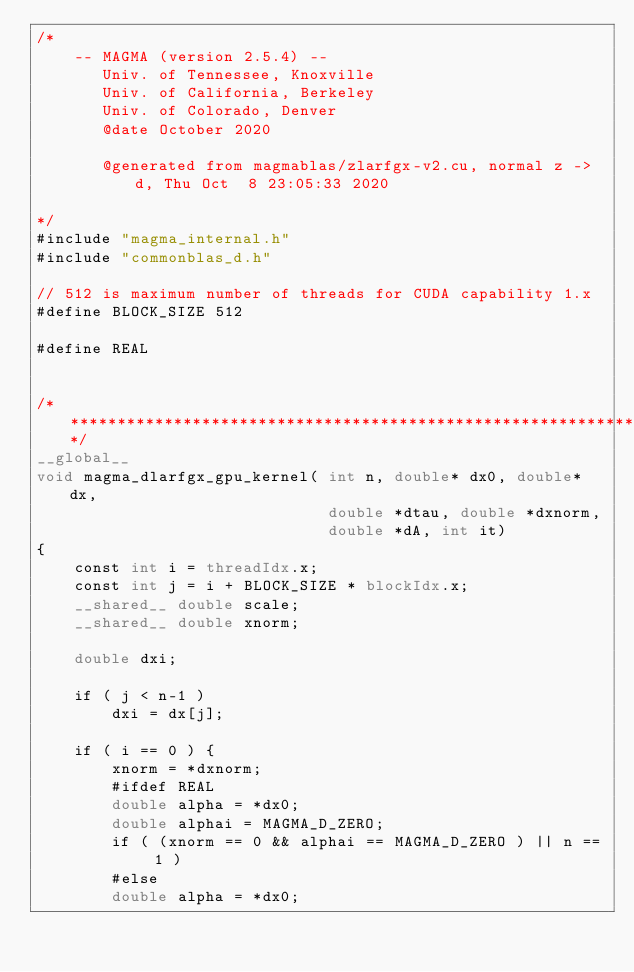<code> <loc_0><loc_0><loc_500><loc_500><_Cuda_>/*
    -- MAGMA (version 2.5.4) --
       Univ. of Tennessee, Knoxville
       Univ. of California, Berkeley
       Univ. of Colorado, Denver
       @date October 2020

       @generated from magmablas/zlarfgx-v2.cu, normal z -> d, Thu Oct  8 23:05:33 2020

*/
#include "magma_internal.h"
#include "commonblas_d.h"

// 512 is maximum number of threads for CUDA capability 1.x
#define BLOCK_SIZE 512

#define REAL


/******************************************************************************/
__global__
void magma_dlarfgx_gpu_kernel( int n, double* dx0, double* dx,
                               double *dtau, double *dxnorm,
                               double *dA, int it)
{
    const int i = threadIdx.x;
    const int j = i + BLOCK_SIZE * blockIdx.x;
    __shared__ double scale;
    __shared__ double xnorm;
  
    double dxi;

    if ( j < n-1 )
        dxi = dx[j];
  
    if ( i == 0 ) {
        xnorm = *dxnorm;
        #ifdef REAL
        double alpha = *dx0;
        double alphai = MAGMA_D_ZERO;
        if ( (xnorm == 0 && alphai == MAGMA_D_ZERO ) || n == 1 )
        #else
        double alpha = *dx0;</code> 